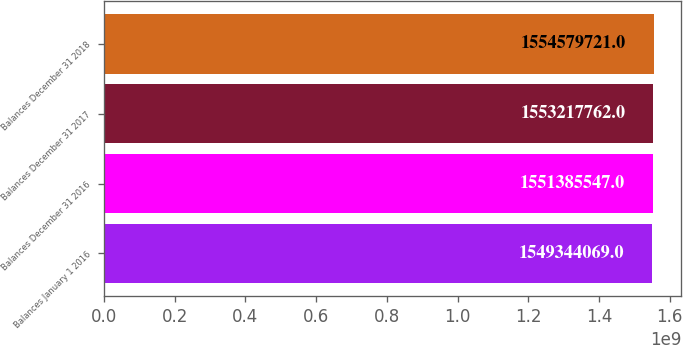<chart> <loc_0><loc_0><loc_500><loc_500><bar_chart><fcel>Balances January 1 2016<fcel>Balances December 31 2016<fcel>Balances December 31 2017<fcel>Balances December 31 2018<nl><fcel>1.54934e+09<fcel>1.55139e+09<fcel>1.55322e+09<fcel>1.55458e+09<nl></chart> 